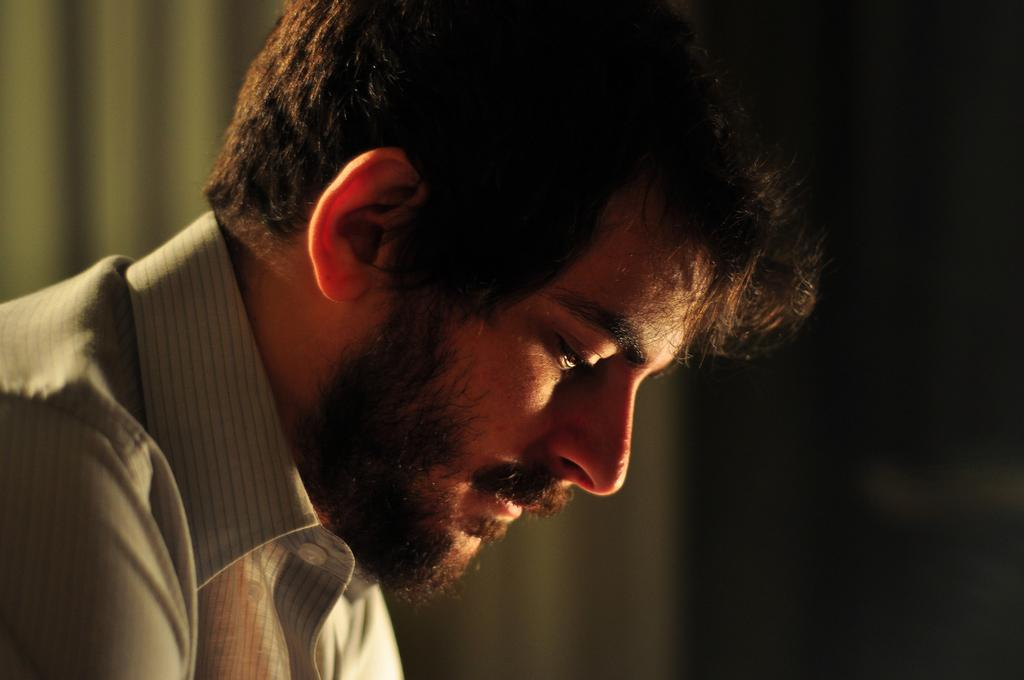Who is present in the image? There is a man in the image. What is the man wearing? The man is wearing a shirt. What can be seen in the background of the image? There is a curtain in the background of the image. Can you hear the goat making any sounds in the image? There is no goat present in the image, so it is not possible to hear any sounds made by a goat. 